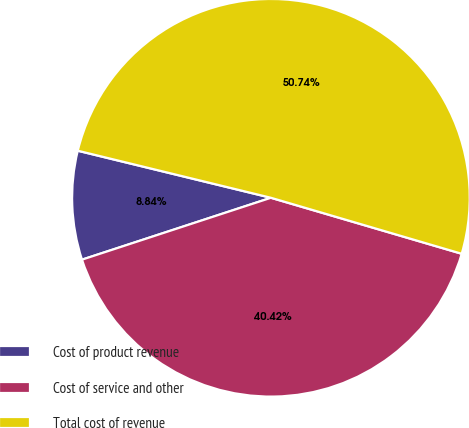<chart> <loc_0><loc_0><loc_500><loc_500><pie_chart><fcel>Cost of product revenue<fcel>Cost of service and other<fcel>Total cost of revenue<nl><fcel>8.84%<fcel>40.42%<fcel>50.74%<nl></chart> 